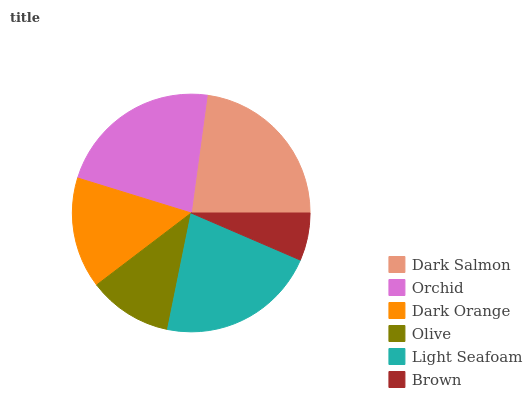Is Brown the minimum?
Answer yes or no. Yes. Is Dark Salmon the maximum?
Answer yes or no. Yes. Is Orchid the minimum?
Answer yes or no. No. Is Orchid the maximum?
Answer yes or no. No. Is Dark Salmon greater than Orchid?
Answer yes or no. Yes. Is Orchid less than Dark Salmon?
Answer yes or no. Yes. Is Orchid greater than Dark Salmon?
Answer yes or no. No. Is Dark Salmon less than Orchid?
Answer yes or no. No. Is Light Seafoam the high median?
Answer yes or no. Yes. Is Dark Orange the low median?
Answer yes or no. Yes. Is Brown the high median?
Answer yes or no. No. Is Light Seafoam the low median?
Answer yes or no. No. 